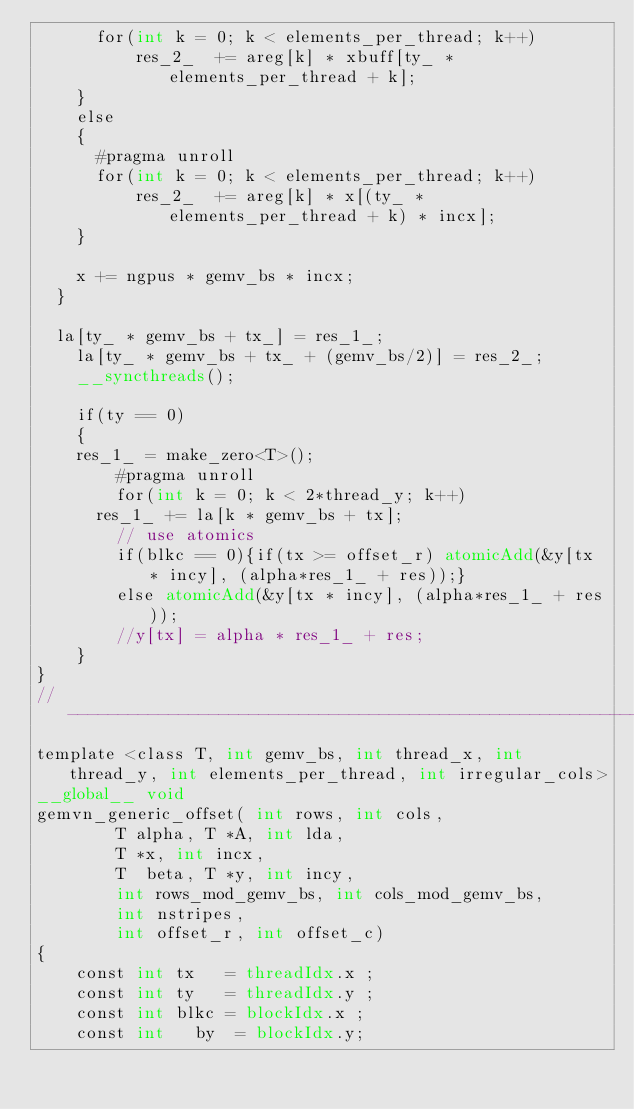<code> <loc_0><loc_0><loc_500><loc_500><_Cuda_>			for(int k = 0; k < elements_per_thread; k++)
	  			res_2_ 	+= areg[k] * xbuff[ty_ * elements_per_thread + k];
		}
		else
		{
			#pragma unroll
			for(int k = 0; k < elements_per_thread; k++)
	  			res_2_ 	+= areg[k] * x[(ty_ * elements_per_thread + k) * incx];
		}

		x += ngpus * gemv_bs * incx;
	}

	la[ty_ * gemv_bs + tx_] = res_1_;
    la[ty_ * gemv_bs + tx_ + (gemv_bs/2)] = res_2_;
    __syncthreads();

    if(ty == 0)
    {
		res_1_ = make_zero<T>();
      	#pragma unroll
      	for(int k = 0; k < 2*thread_y; k++)
			res_1_ += la[k * gemv_bs + tx];
      	// use atomics
      	if(blkc == 0){if(tx >= offset_r) atomicAdd(&y[tx * incy], (alpha*res_1_ + res));}
      	else atomicAdd(&y[tx * incy], (alpha*res_1_ + res));
      	//y[tx] = alpha * res_1_ + res;
    }
}
//--------------------------------------------------------------------------------------------------------//
template <class T, int gemv_bs, int thread_x, int thread_y, int elements_per_thread, int irregular_cols>
__global__ void
gemvn_generic_offset(	int rows, int cols,
				T alpha, T *A, int lda,
				T *x, int incx,
				T  beta, T *y, int incy,
				int rows_mod_gemv_bs, int cols_mod_gemv_bs,
				int nstripes,
				int offset_r, int offset_c)
{
    const int	tx   = threadIdx.x ;
    const int	ty   = threadIdx.y ;
    const int	blkc = blockIdx.x ;
    const int 	by 	= blockIdx.y;</code> 